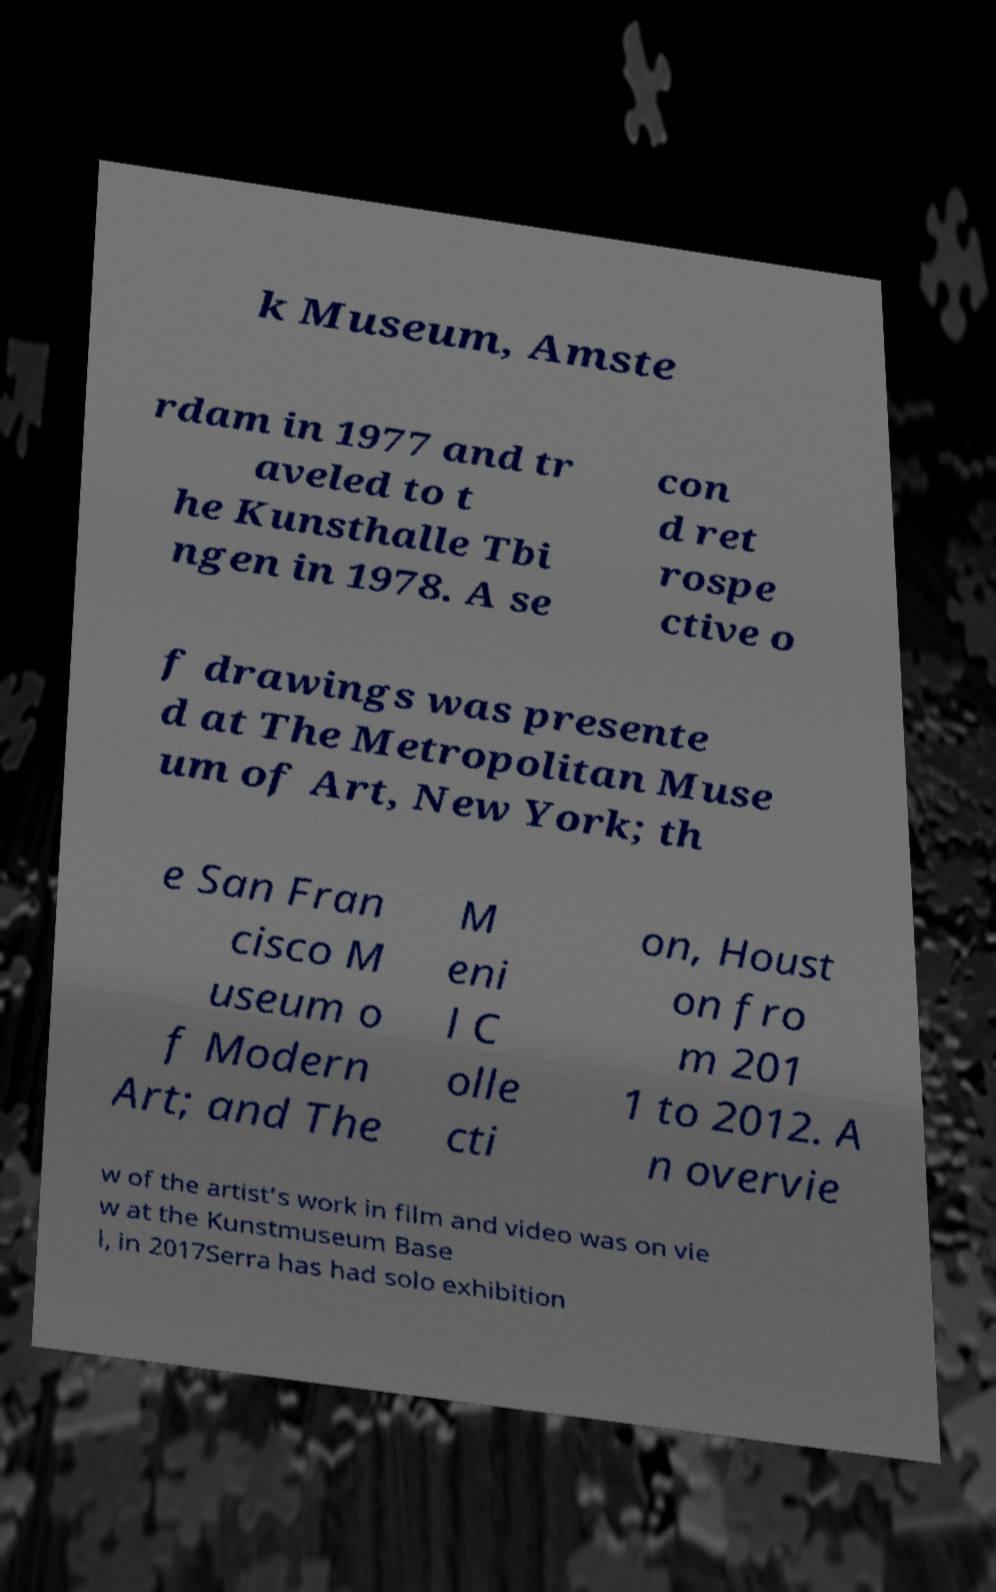For documentation purposes, I need the text within this image transcribed. Could you provide that? k Museum, Amste rdam in 1977 and tr aveled to t he Kunsthalle Tbi ngen in 1978. A se con d ret rospe ctive o f drawings was presente d at The Metropolitan Muse um of Art, New York; th e San Fran cisco M useum o f Modern Art; and The M eni l C olle cti on, Houst on fro m 201 1 to 2012. A n overvie w of the artist’s work in film and video was on vie w at the Kunstmuseum Base l, in 2017Serra has had solo exhibition 